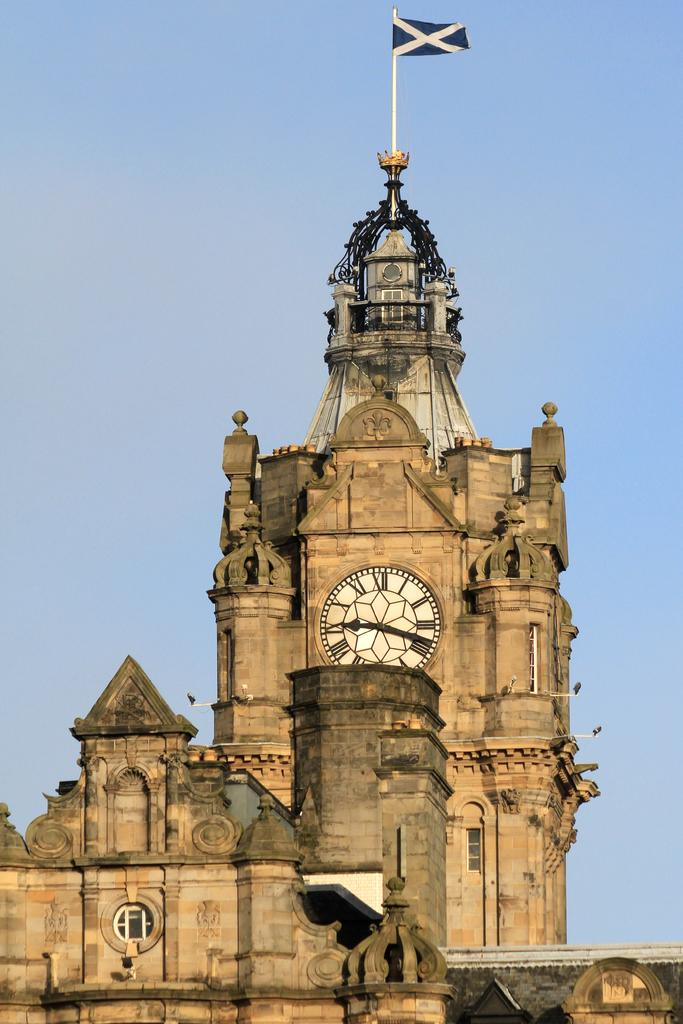What type of structure is present in the image? There is a building in the image. What specific feature can be seen on the building? There is a clock tower in the image. What is attached to the flag post? There is a flag in the image. What is the location of the flag post? The flag post is in the image. What can be seen in the background of the image? The sky is visible in the background of the image. What type of ground is visible beneath the building in the image? There is no specific ground type mentioned in the facts provided, and the image does not show the ground beneath the building. 